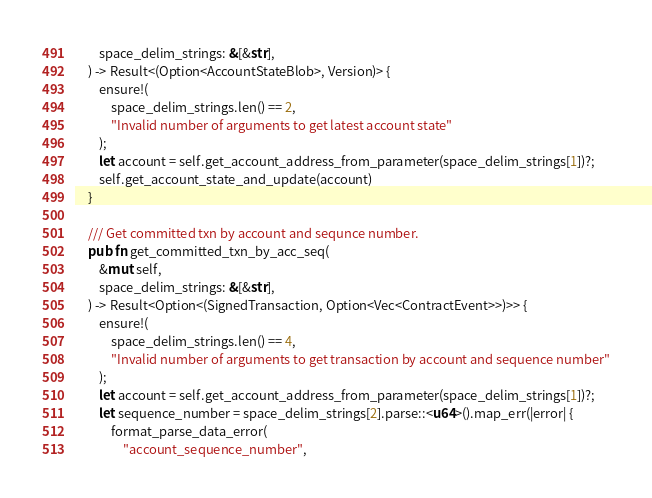<code> <loc_0><loc_0><loc_500><loc_500><_Rust_>        space_delim_strings: &[&str],
    ) -> Result<(Option<AccountStateBlob>, Version)> {
        ensure!(
            space_delim_strings.len() == 2,
            "Invalid number of arguments to get latest account state"
        );
        let account = self.get_account_address_from_parameter(space_delim_strings[1])?;
        self.get_account_state_and_update(account)
    }

    /// Get committed txn by account and sequnce number.
    pub fn get_committed_txn_by_acc_seq(
        &mut self,
        space_delim_strings: &[&str],
    ) -> Result<Option<(SignedTransaction, Option<Vec<ContractEvent>>)>> {
        ensure!(
            space_delim_strings.len() == 4,
            "Invalid number of arguments to get transaction by account and sequence number"
        );
        let account = self.get_account_address_from_parameter(space_delim_strings[1])?;
        let sequence_number = space_delim_strings[2].parse::<u64>().map_err(|error| {
            format_parse_data_error(
                "account_sequence_number",</code> 